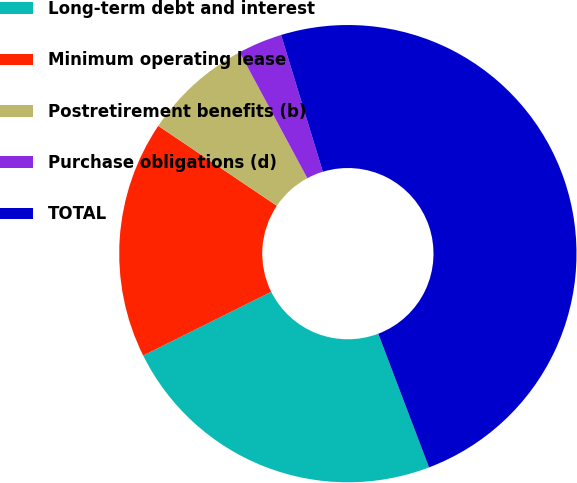<chart> <loc_0><loc_0><loc_500><loc_500><pie_chart><fcel>Long-term debt and interest<fcel>Minimum operating lease<fcel>Postretirement benefits (b)<fcel>Purchase obligations (d)<fcel>TOTAL<nl><fcel>23.42%<fcel>16.79%<fcel>7.71%<fcel>3.13%<fcel>48.94%<nl></chart> 